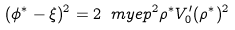Convert formula to latex. <formula><loc_0><loc_0><loc_500><loc_500>( \phi ^ { * } - \xi ) ^ { 2 } = 2 \ m y e p ^ { 2 } \rho ^ { * } V _ { 0 } ^ { \prime } ( \rho ^ { * } ) ^ { 2 }</formula> 